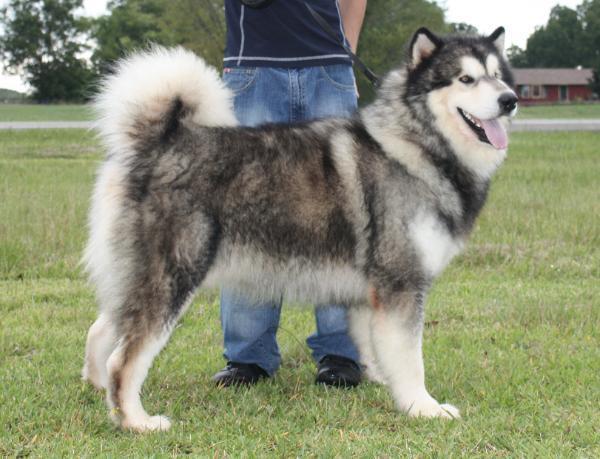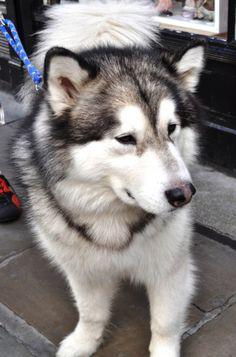The first image is the image on the left, the second image is the image on the right. For the images shown, is this caption "The dogs in both pictures are looking to the right." true? Answer yes or no. Yes. The first image is the image on the left, the second image is the image on the right. For the images shown, is this caption "The left image features a dog with an open mouth standing in profile in front of someone standing wearing pants." true? Answer yes or no. Yes. 